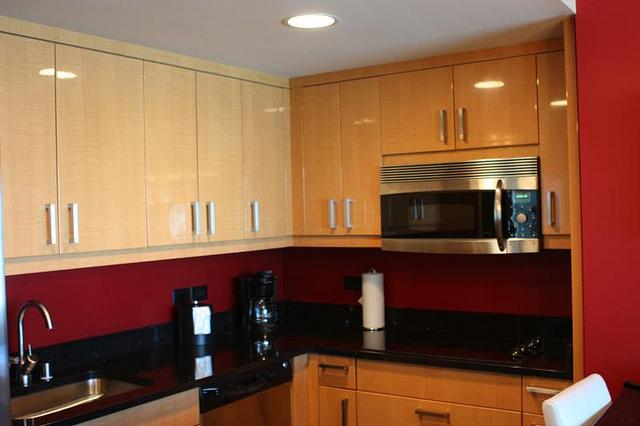What material is the sink made of? Please explain your reasoning. stainless steel. It is shiny and metal 